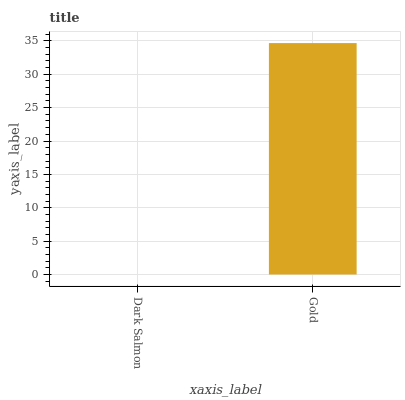Is Dark Salmon the minimum?
Answer yes or no. Yes. Is Gold the maximum?
Answer yes or no. Yes. Is Gold the minimum?
Answer yes or no. No. Is Gold greater than Dark Salmon?
Answer yes or no. Yes. Is Dark Salmon less than Gold?
Answer yes or no. Yes. Is Dark Salmon greater than Gold?
Answer yes or no. No. Is Gold less than Dark Salmon?
Answer yes or no. No. Is Gold the high median?
Answer yes or no. Yes. Is Dark Salmon the low median?
Answer yes or no. Yes. Is Dark Salmon the high median?
Answer yes or no. No. Is Gold the low median?
Answer yes or no. No. 